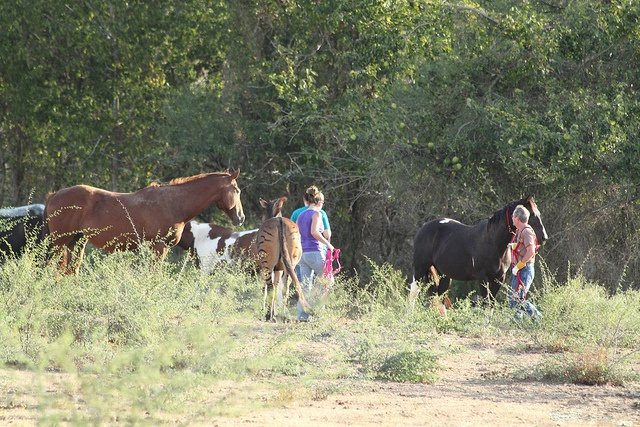Describe the objects in this image and their specific colors. I can see horse in darkgreen, brown, maroon, and tan tones, horse in darkgreen, black, gray, and ivory tones, people in darkgreen, blue, darkgray, white, and lightpink tones, people in darkgreen, white, darkgray, gray, and brown tones, and people in darkgreen, white, gray, lightblue, and teal tones in this image. 